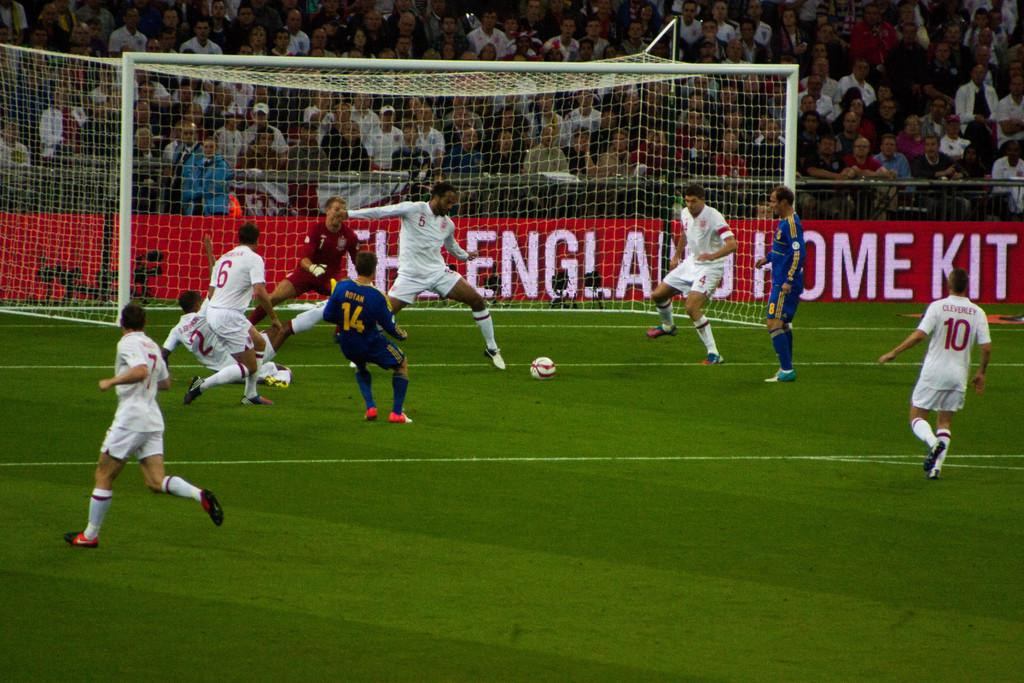What activity are the people in the image engaged in? The people in the image are playing football. What is used to mark the goal in the game? There is a goal pole in the image. Who is watching the people play football? There is an audience visible in the image. What can be seen on the hoarding in the image? There is text on a hoarding in the image. How many dogs are playing with the comb in the image? There are no dogs or combs present in the image. What type of machine is visible in the background of the image? There is no machine visible in the image; it features people playing football, a goal pole, an audience, and text on a hoarding. 